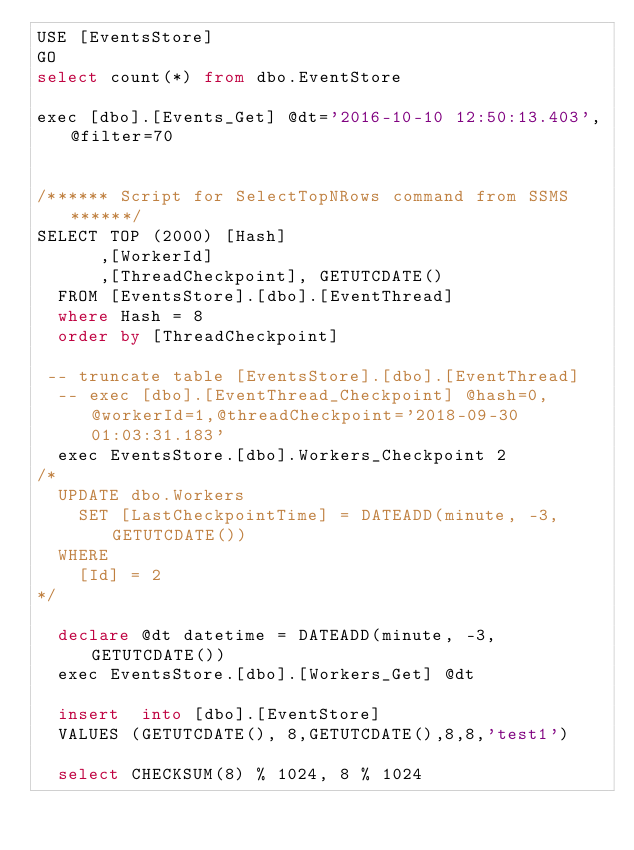<code> <loc_0><loc_0><loc_500><loc_500><_SQL_>USE [EventsStore]
GO
select count(*) from dbo.EventStore

exec [dbo].[Events_Get] @dt='2016-10-10 12:50:13.403',@filter=70


/****** Script for SelectTopNRows command from SSMS  ******/
SELECT TOP (2000) [Hash]
      ,[WorkerId]
      ,[ThreadCheckpoint], GETUTCDATE()
  FROM [EventsStore].[dbo].[EventThread]
  where Hash = 8
  order by [ThreadCheckpoint]

 -- truncate table [EventsStore].[dbo].[EventThread]
  -- exec [dbo].[EventThread_Checkpoint] @hash=0,@workerId=1,@threadCheckpoint='2018-09-30 01:03:31.183'
  exec EventsStore.[dbo].Workers_Checkpoint 2
/*
	UPDATE dbo.Workers
		SET [LastCheckpointTime] = DATEADD(minute, -3, GETUTCDATE())
	WHERE	
		[Id] = 2
*/

  declare @dt datetime = DATEADD(minute, -3, GETUTCDATE())
  exec EventsStore.[dbo].[Workers_Get] @dt

  insert  into [dbo].[EventStore]  
  VALUES (GETUTCDATE(), 8,GETUTCDATE(),8,8,'test1')

  select CHECKSUM(8) % 1024, 8 % 1024</code> 